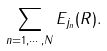Convert formula to latex. <formula><loc_0><loc_0><loc_500><loc_500>\sum _ { n = 1 , \cdots , N } E _ { j _ { n } } ( R ) .</formula> 